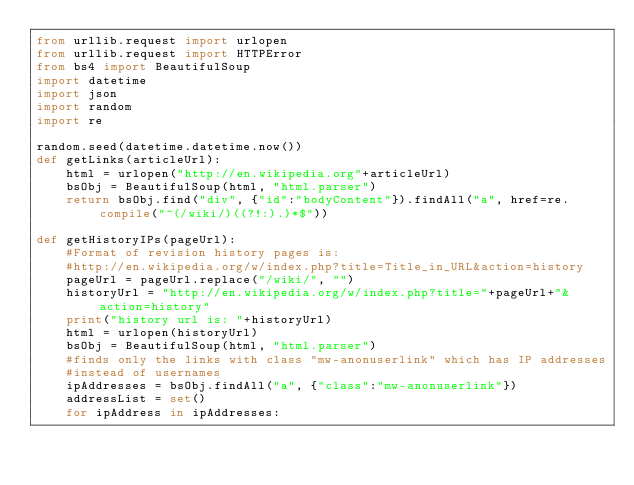Convert code to text. <code><loc_0><loc_0><loc_500><loc_500><_Python_>from urllib.request import urlopen
from urllib.request import HTTPError
from bs4 import BeautifulSoup
import datetime
import json
import random
import re

random.seed(datetime.datetime.now())
def getLinks(articleUrl):
    html = urlopen("http://en.wikipedia.org"+articleUrl)
    bsObj = BeautifulSoup(html, "html.parser")
    return bsObj.find("div", {"id":"bodyContent"}).findAll("a", href=re.compile("^(/wiki/)((?!:).)*$"))

def getHistoryIPs(pageUrl):
    #Format of revision history pages is: 
    #http://en.wikipedia.org/w/index.php?title=Title_in_URL&action=history
    pageUrl = pageUrl.replace("/wiki/", "")
    historyUrl = "http://en.wikipedia.org/w/index.php?title="+pageUrl+"&action=history"
    print("history url is: "+historyUrl)
    html = urlopen(historyUrl)
    bsObj = BeautifulSoup(html, "html.parser")
    #finds only the links with class "mw-anonuserlink" which has IP addresses 
    #instead of usernames
    ipAddresses = bsObj.findAll("a", {"class":"mw-anonuserlink"})
    addressList = set()
    for ipAddress in ipAddresses:</code> 